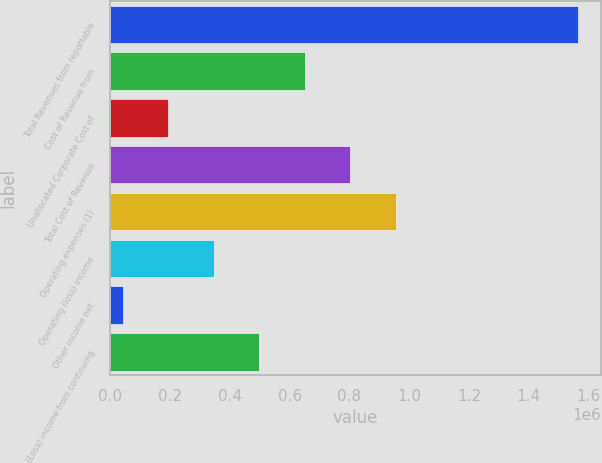<chart> <loc_0><loc_0><loc_500><loc_500><bar_chart><fcel>Total Revenues from reportable<fcel>Cost of Revenue from<fcel>Unallocated Corporate Cost of<fcel>Total Cost of Revenue<fcel>Operating expenses (1)<fcel>Operating (loss) income<fcel>Other income net<fcel>(Loss) income from continuing<nl><fcel>1.563e+06<fcel>650785<fcel>194678<fcel>802820<fcel>954856<fcel>346714<fcel>42643<fcel>498750<nl></chart> 